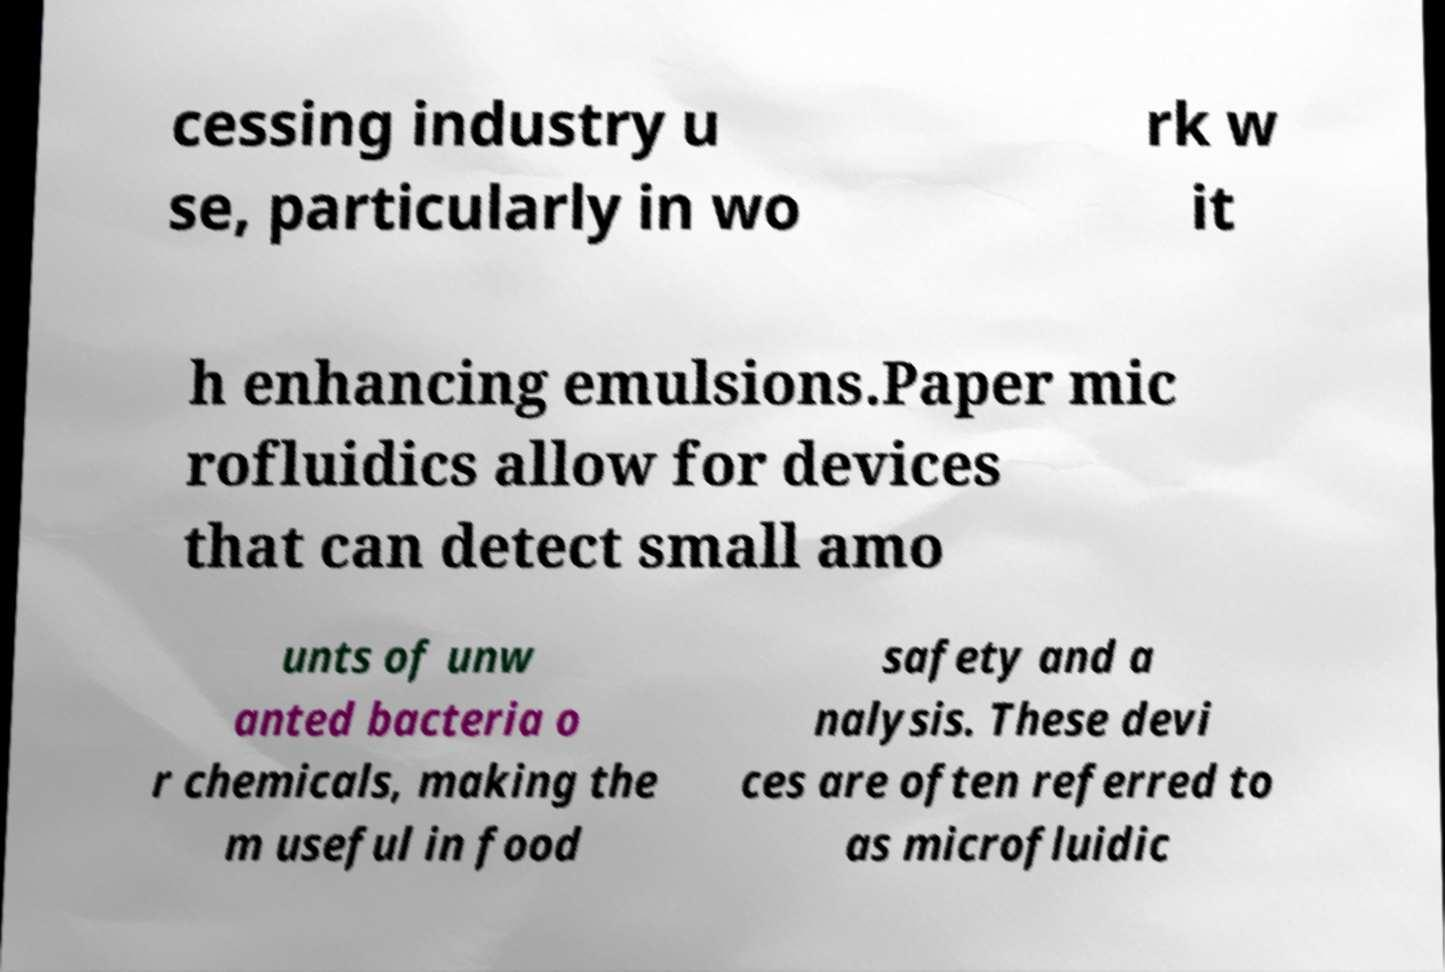There's text embedded in this image that I need extracted. Can you transcribe it verbatim? cessing industry u se, particularly in wo rk w it h enhancing emulsions.Paper mic rofluidics allow for devices that can detect small amo unts of unw anted bacteria o r chemicals, making the m useful in food safety and a nalysis. These devi ces are often referred to as microfluidic 